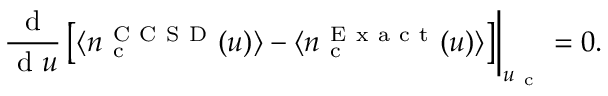<formula> <loc_0><loc_0><loc_500><loc_500>\frac { d } { d u } \left [ \langle n _ { c } ^ { C C S D } ( u ) \rangle - \langle n _ { c } ^ { E x a c t } ( u ) \rangle \right ] \right | _ { u _ { c } } = 0 .</formula> 